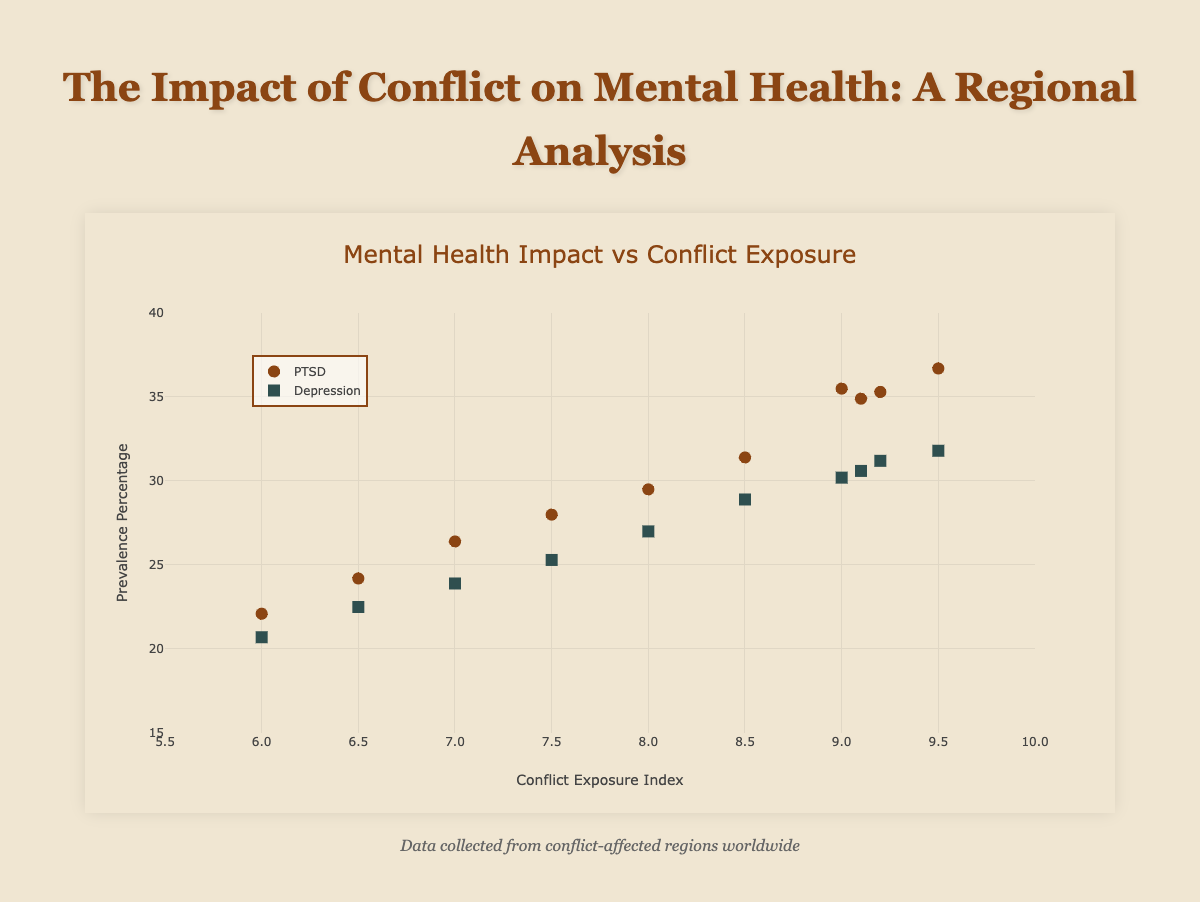What's the title of the scatter plot? The title is located at the top of and describes the focus of the scatter plot.
Answer: Mental Health Impact vs Conflict Exposure What does the x-axis represent in the scatter plot? The x-axis is labeled to show the variable it represents.
Answer: Conflict Exposure Index What does the y-axis represent in the scatter plot? The y-axis is labeled to show the variable it represents.
Answer: Prevalence Percentage How many data points are there in total on the scatter plot? Each data point corresponds to one region, and we need to count these points.
Answer: 10 Which region has the highest Conflict Exposure Index? The region with the highest Conflict Exposure Index will be the one farthest to the right on the x-axis.
Answer: Gaza Which region has the lowest PTSD prevalence percentage? The region with the lowest PTSD prevalence percentage will be the one with the lowest value on the y-axis from the PTSD dataset.
Answer: Kiev Compare the PTSD prevalence percentage between Gaza and Mogadishu. Which one is higher? Gaza and Mogadishu should be found on the scatter plot, compare their respective y-axis values for PTSD prevalence.
Answer: Gaza Which region shows a similar conflict exposure index but different depression prevalence percentages? Look for regions with close x-axis values but significantly different y-axis values for depression.
Answer: Aleppo and Kandahar What is the average PTSD prevalence percentage across all regions? Sum up all the PTSD Prevalence Percentages and divide by the number of regions, which is 10.
Answer: 30.4 Does a higher Conflict Exposure Index generally correlate with higher PTSD and depression prevalence percentages? Observing the trend of both datasets on the scatter plot should give a visual indication of correlation (potential trend).
Answer: Yes 